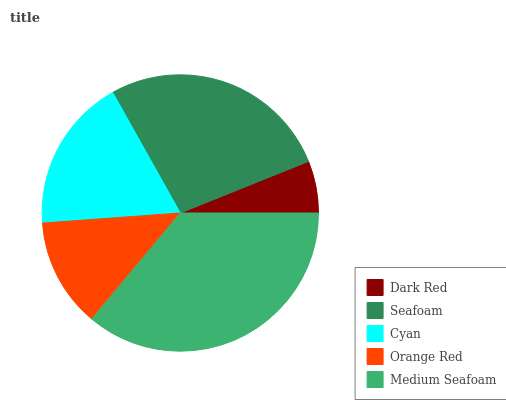Is Dark Red the minimum?
Answer yes or no. Yes. Is Medium Seafoam the maximum?
Answer yes or no. Yes. Is Seafoam the minimum?
Answer yes or no. No. Is Seafoam the maximum?
Answer yes or no. No. Is Seafoam greater than Dark Red?
Answer yes or no. Yes. Is Dark Red less than Seafoam?
Answer yes or no. Yes. Is Dark Red greater than Seafoam?
Answer yes or no. No. Is Seafoam less than Dark Red?
Answer yes or no. No. Is Cyan the high median?
Answer yes or no. Yes. Is Cyan the low median?
Answer yes or no. Yes. Is Seafoam the high median?
Answer yes or no. No. Is Dark Red the low median?
Answer yes or no. No. 